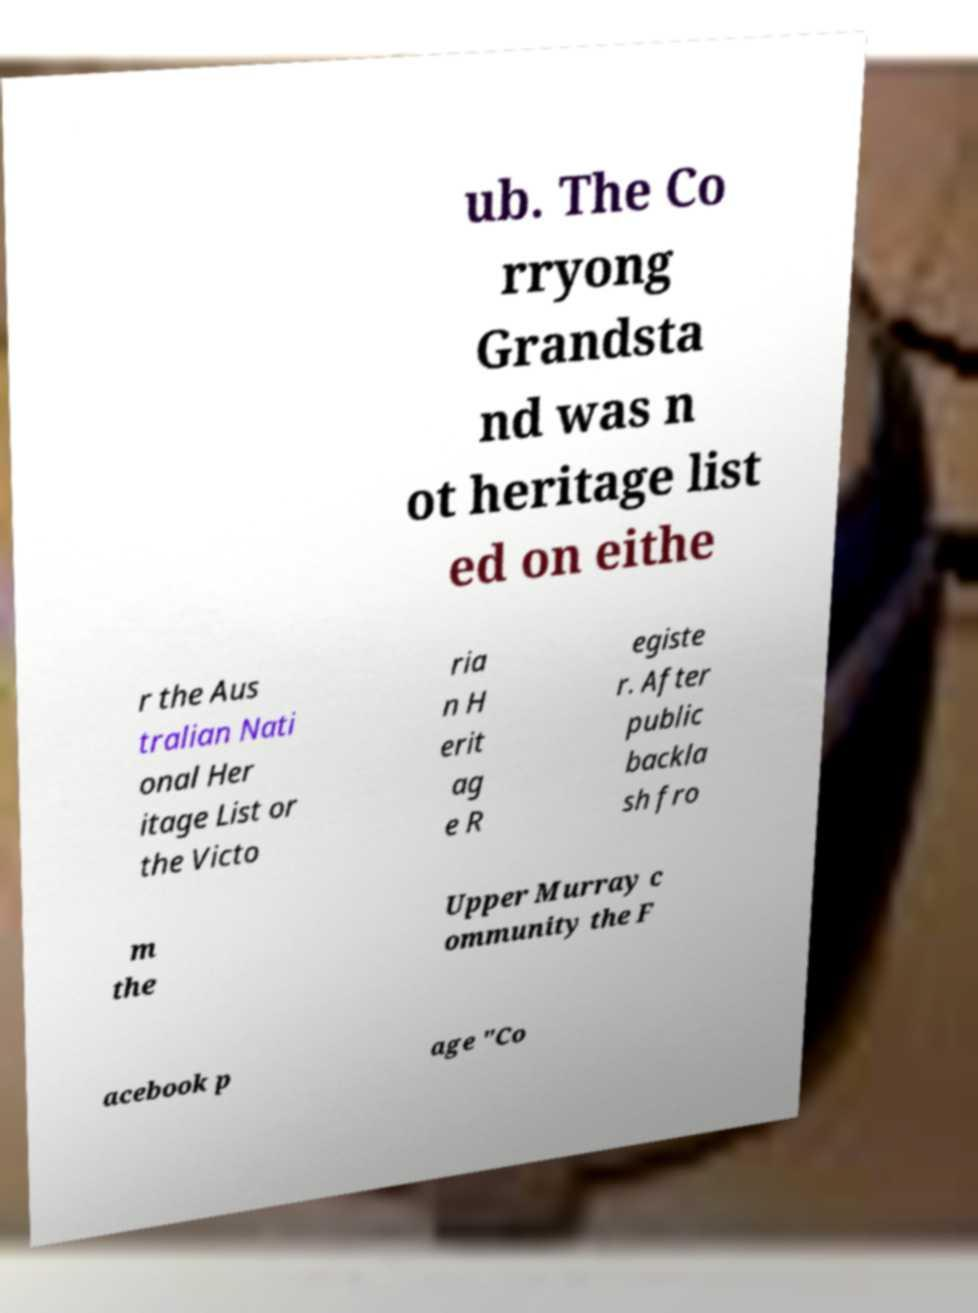Can you accurately transcribe the text from the provided image for me? ub. The Co rryong Grandsta nd was n ot heritage list ed on eithe r the Aus tralian Nati onal Her itage List or the Victo ria n H erit ag e R egiste r. After public backla sh fro m the Upper Murray c ommunity the F acebook p age "Co 